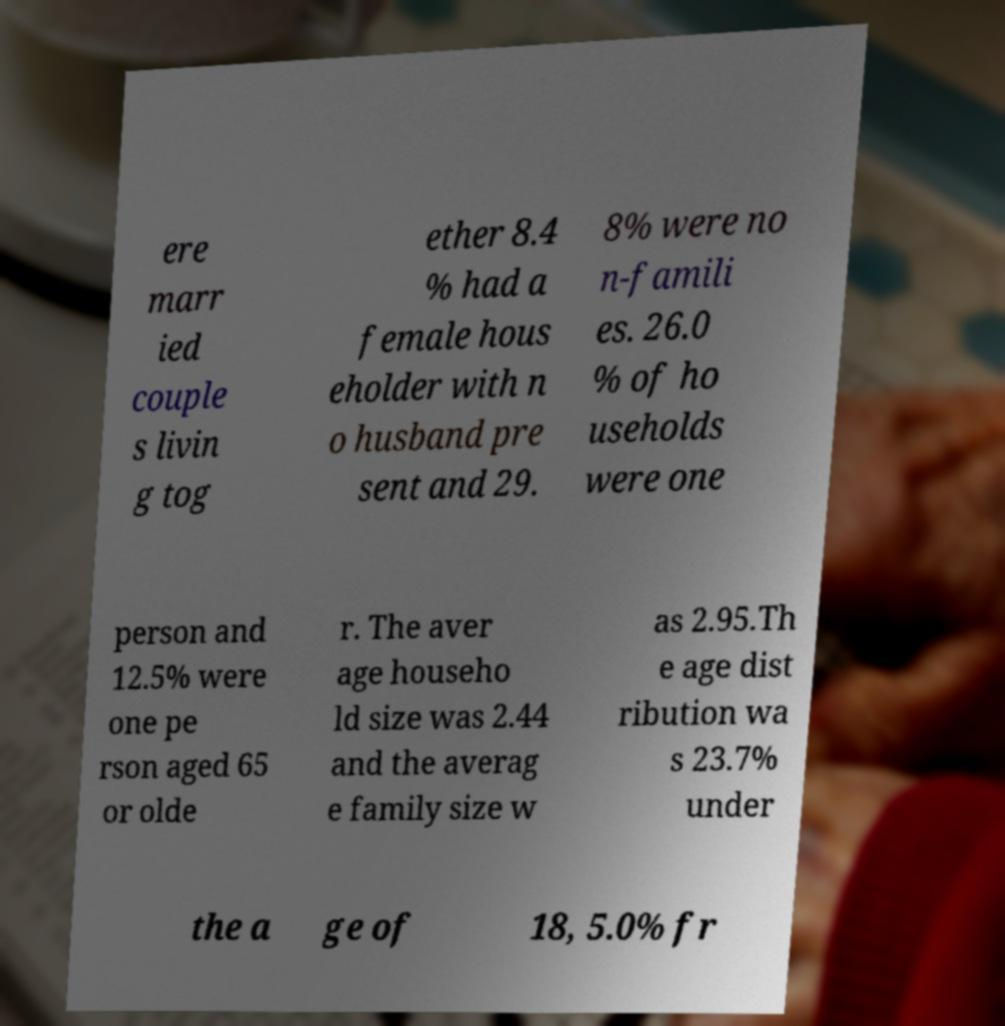Please read and relay the text visible in this image. What does it say? ere marr ied couple s livin g tog ether 8.4 % had a female hous eholder with n o husband pre sent and 29. 8% were no n-famili es. 26.0 % of ho useholds were one person and 12.5% were one pe rson aged 65 or olde r. The aver age househo ld size was 2.44 and the averag e family size w as 2.95.Th e age dist ribution wa s 23.7% under the a ge of 18, 5.0% fr 